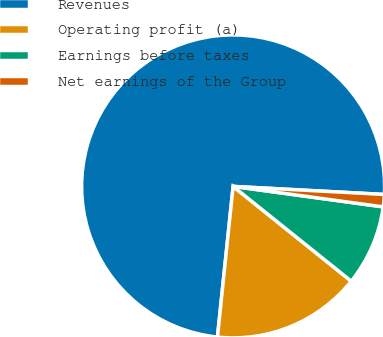<chart> <loc_0><loc_0><loc_500><loc_500><pie_chart><fcel>Revenues<fcel>Operating profit (a)<fcel>Earnings before taxes<fcel>Net earnings of the Group<nl><fcel>74.2%<fcel>15.89%<fcel>8.6%<fcel>1.31%<nl></chart> 